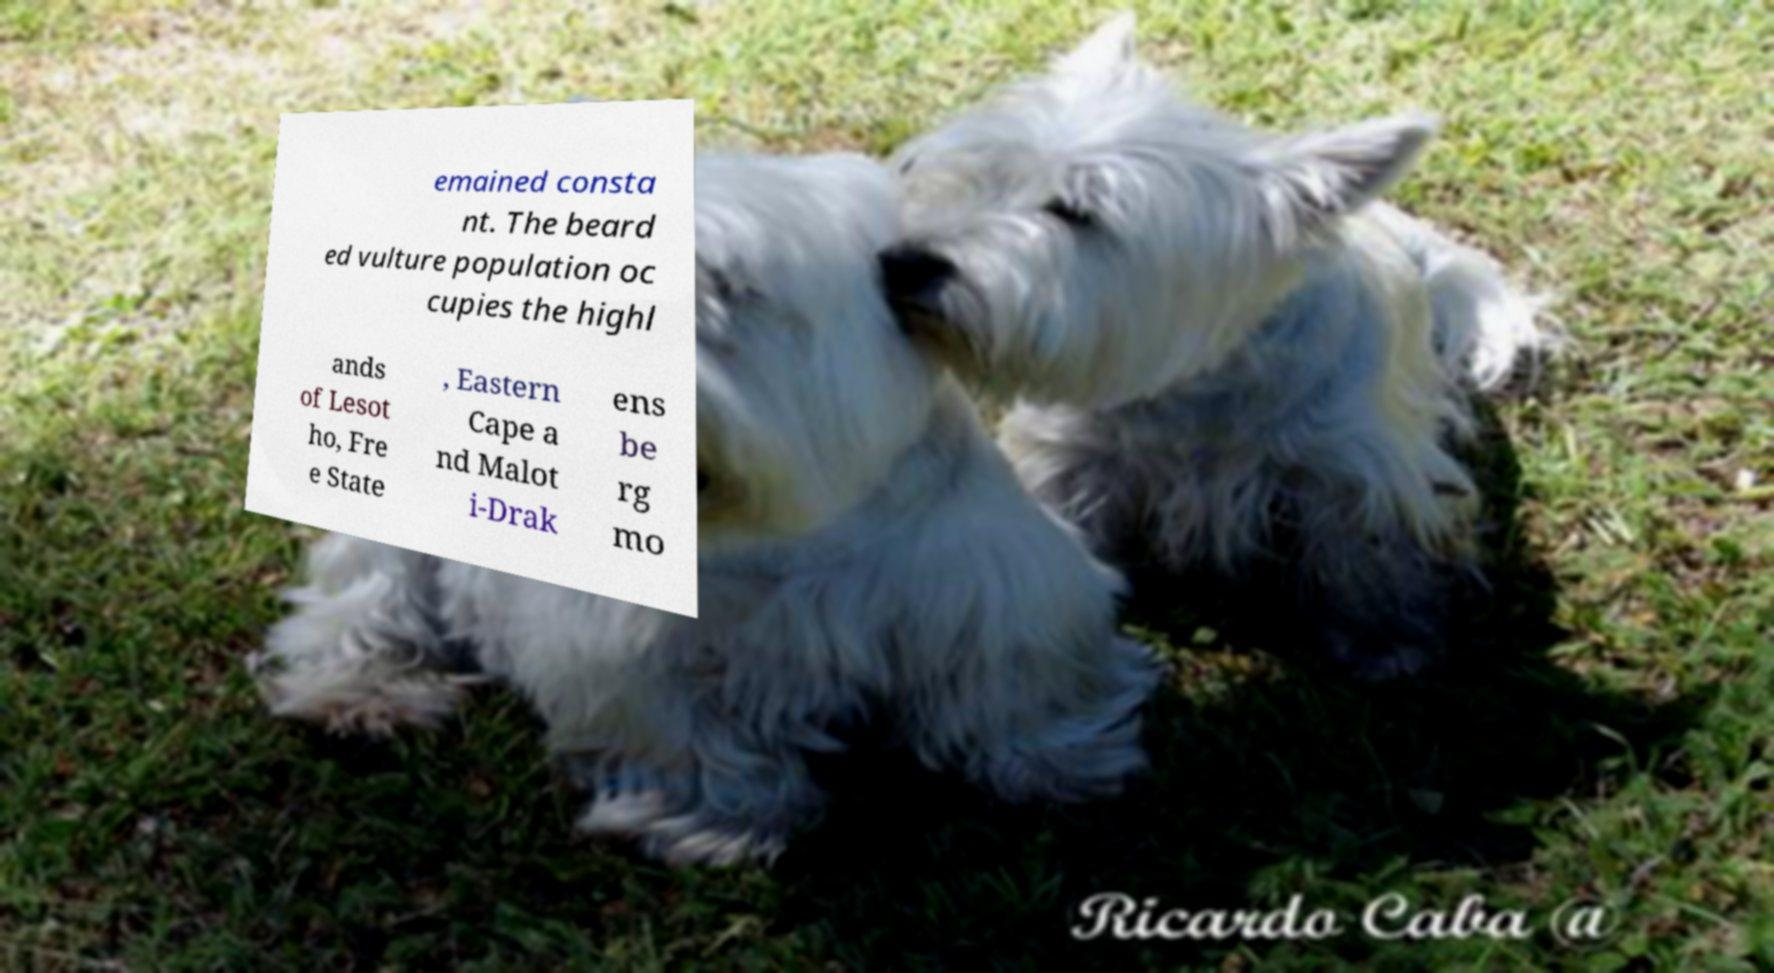There's text embedded in this image that I need extracted. Can you transcribe it verbatim? emained consta nt. The beard ed vulture population oc cupies the highl ands of Lesot ho, Fre e State , Eastern Cape a nd Malot i-Drak ens be rg mo 